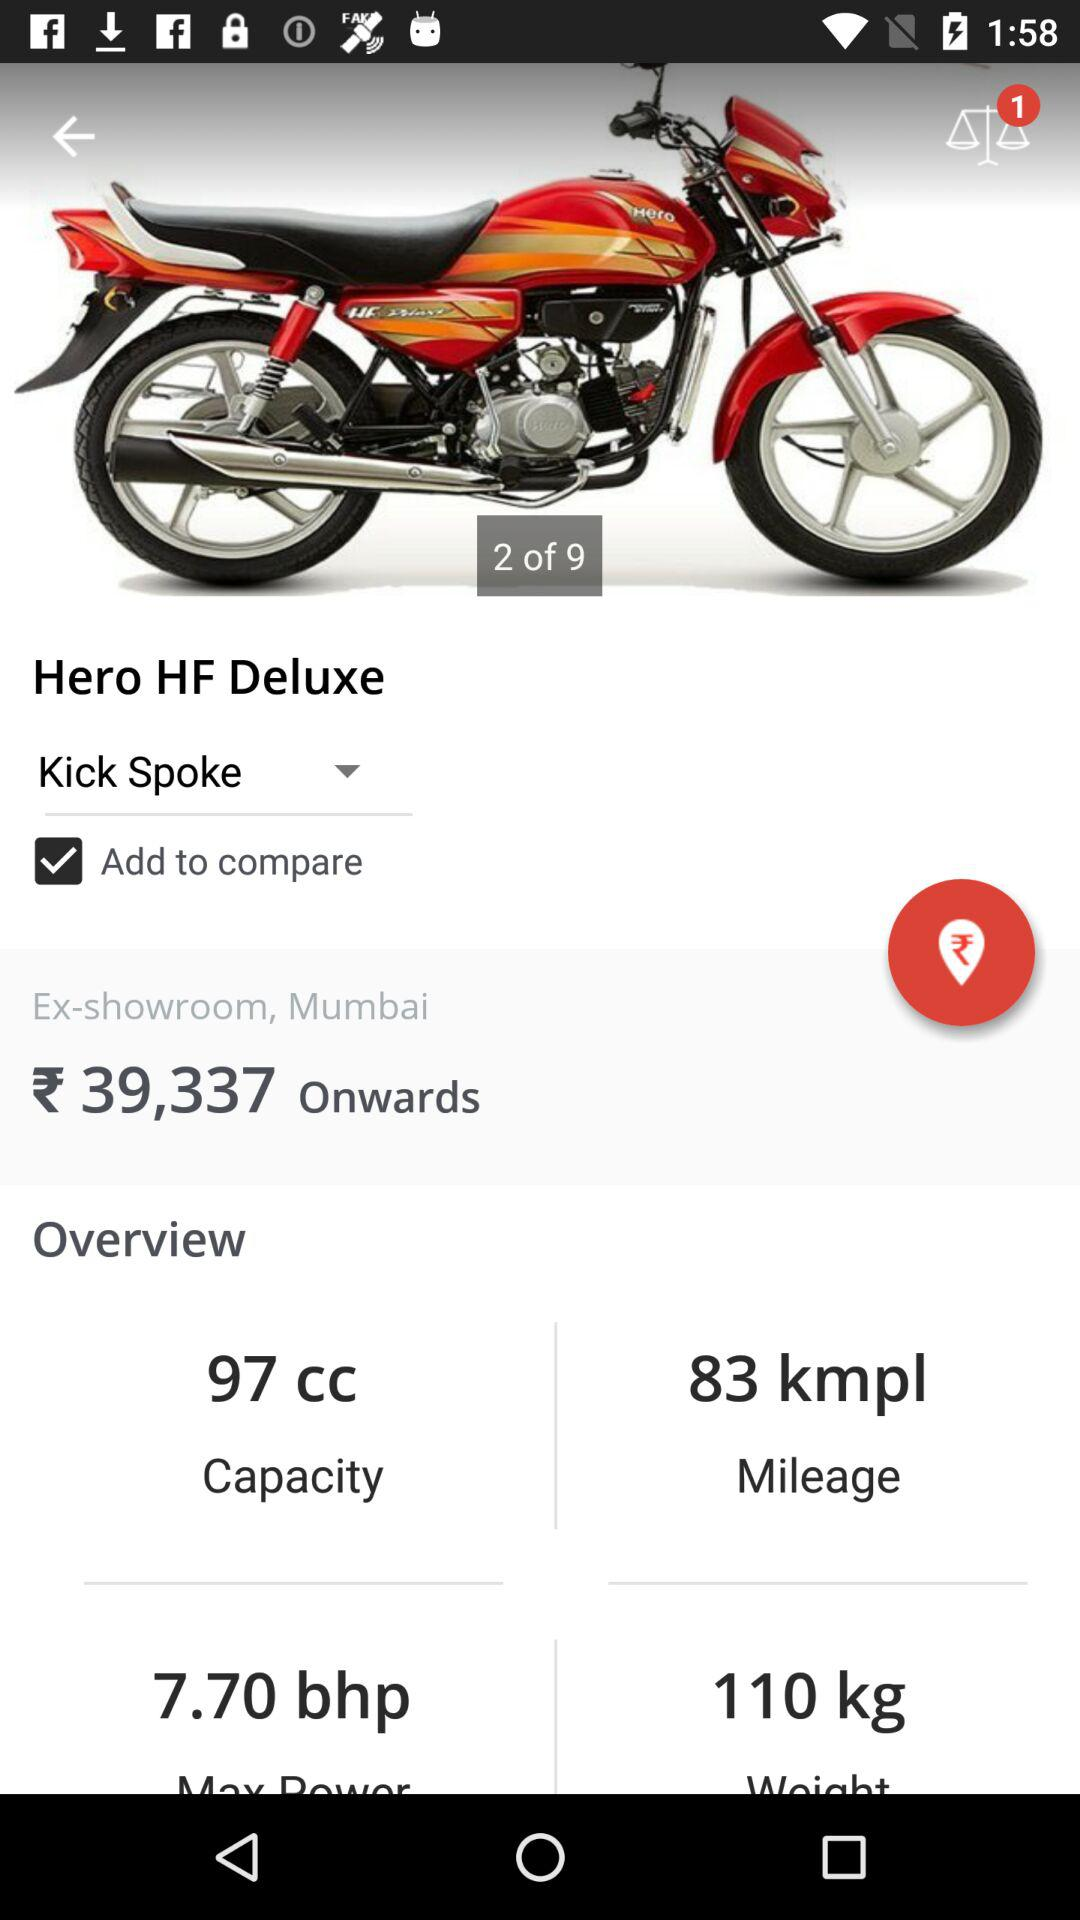What is the ex-showroom price of "Hero HF Deluxe"? The ex-showroom price is ₹39,337 onwards. 